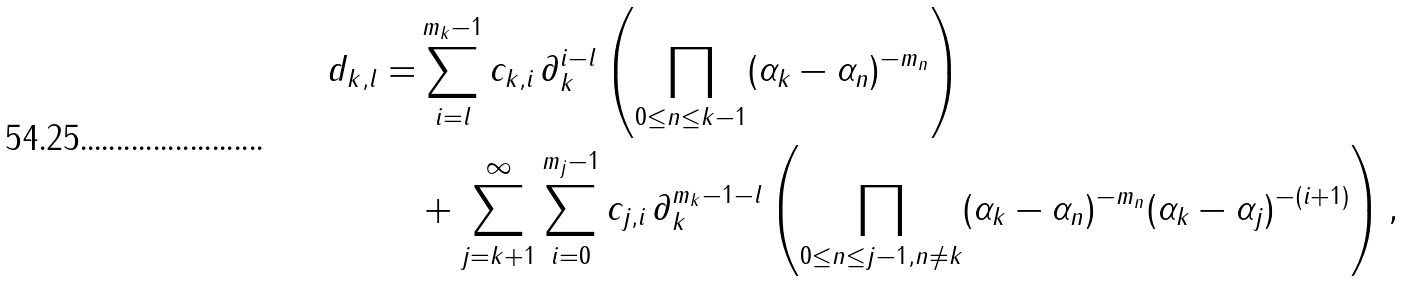Convert formula to latex. <formula><loc_0><loc_0><loc_500><loc_500>d _ { k , l } = & \sum _ { i = l } ^ { m _ { k } - 1 } c _ { k , i } \, \partial _ { k } ^ { i - l } \left ( \prod _ { 0 \leq n \leq k - 1 } ( \alpha _ { k } - \alpha _ { n } ) ^ { - m _ { n } } \right ) \\ & + \sum _ { j = k + 1 } ^ { \infty } \sum _ { i = 0 } ^ { m _ { j } - 1 } c _ { j , i } \, \partial _ { k } ^ { m _ { k } - 1 - l } \left ( \prod _ { 0 \leq n \leq j - 1 , n \not = k } ( \alpha _ { k } - \alpha _ { n } ) ^ { - m _ { n } } ( \alpha _ { k } - \alpha _ { j } ) ^ { - ( i + 1 ) } \right ) ,</formula> 